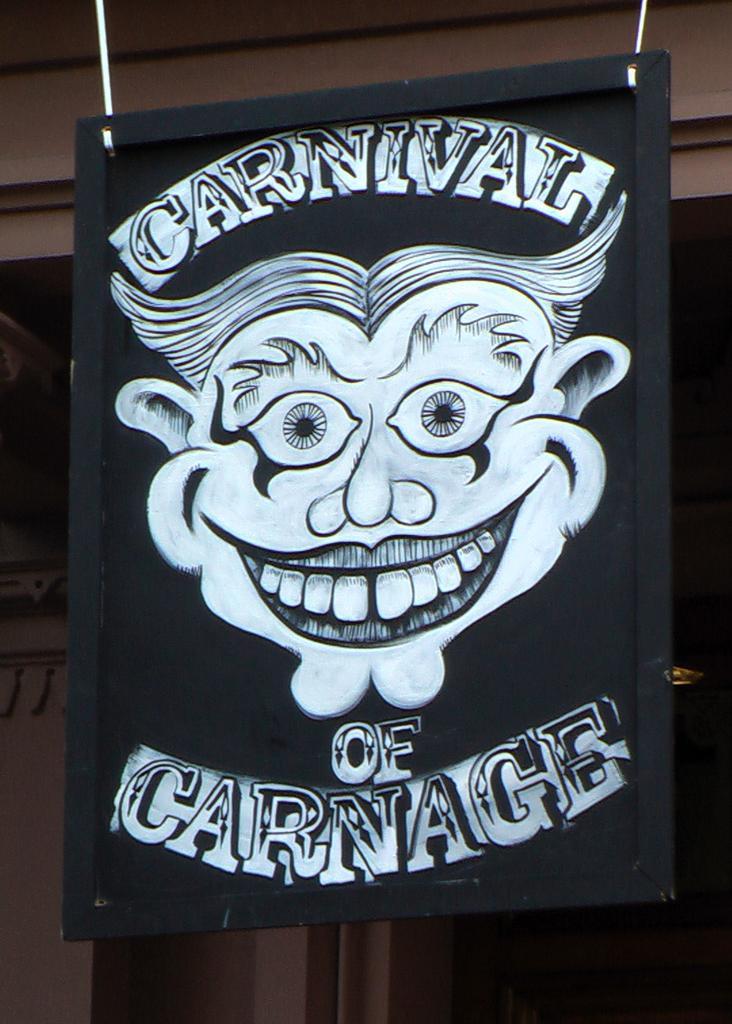Please provide a concise description of this image. This image consists of a board in black color. It is hanged to the roof. On which we can see a joker face along with the text. 